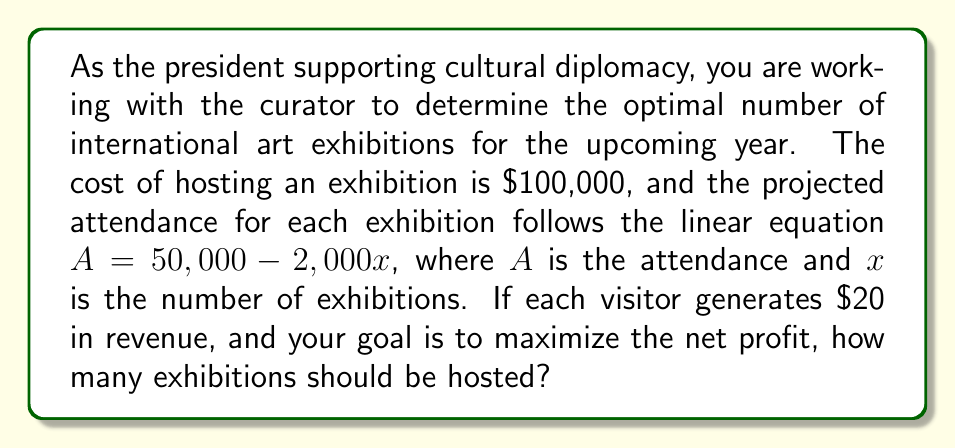Show me your answer to this math problem. To solve this problem, we need to follow these steps:

1. Define the profit function:
   Let $P(x)$ be the profit function, where $x$ is the number of exhibitions.
   
   $$P(x) = \text{Revenue} - \text{Cost}$$

2. Calculate the revenue:
   Revenue = Number of visitors × Revenue per visitor
   $$R(x) = (50,000 - 2,000x) \times 20 = 1,000,000 - 40,000x$$

3. Calculate the cost:
   Cost = Number of exhibitions × Cost per exhibition
   $$C(x) = 100,000x$$

4. Form the profit function:
   $$P(x) = R(x) - C(x) = (1,000,000 - 40,000x) - 100,000x$$
   $$P(x) = 1,000,000 - 140,000x$$

5. To find the maximum profit, we need to find the vertex of this quadratic function. Since it's a linear function, the maximum will occur at one of the endpoints. We need to consider the domain of $x$:
   - Minimum exhibitions: 0
   - Maximum exhibitions: When attendance reaches 0
     $50,000 - 2,000x = 0$
     $x = 25$

6. Calculate profit at these points:
   $P(0) = 1,000,000 - 140,000(0) = 1,000,000$
   $P(25) = 1,000,000 - 140,000(25) = -2,500,000$

7. The maximum profit occurs at $x = 0$, but this means no exhibitions. The next best integer solution is $x = 1$.

8. Check profit at $x = 1$:
   $P(1) = 1,000,000 - 140,000(1) = 860,000$

Therefore, to maximize profit while still hosting exhibitions, you should host 1 exhibition.
Answer: The optimal number of international art exhibitions to maximize profit is 1. 